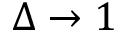<formula> <loc_0><loc_0><loc_500><loc_500>\Delta \rightarrow 1</formula> 